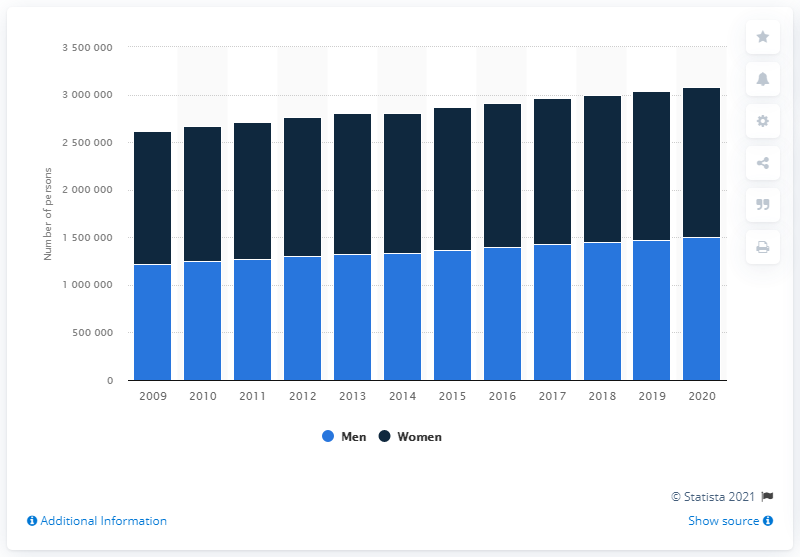Outline some significant characteristics in this image. Since 2009, the number of single individuals living alone has been on the rise. In the Netherlands in 2020, it is estimated that approximately 150,008,150 men were living alone. It is estimated that in 2020, there were approximately 157,8963 single women living in the Netherlands. 